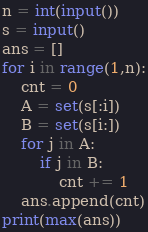<code> <loc_0><loc_0><loc_500><loc_500><_Python_>n = int(input())
s = input()
ans = []
for i in range(1,n):
    cnt = 0
    A = set(s[:i])
    B = set(s[i:])
    for j in A:
        if j in B:
            cnt += 1
    ans.append(cnt)
print(max(ans))</code> 